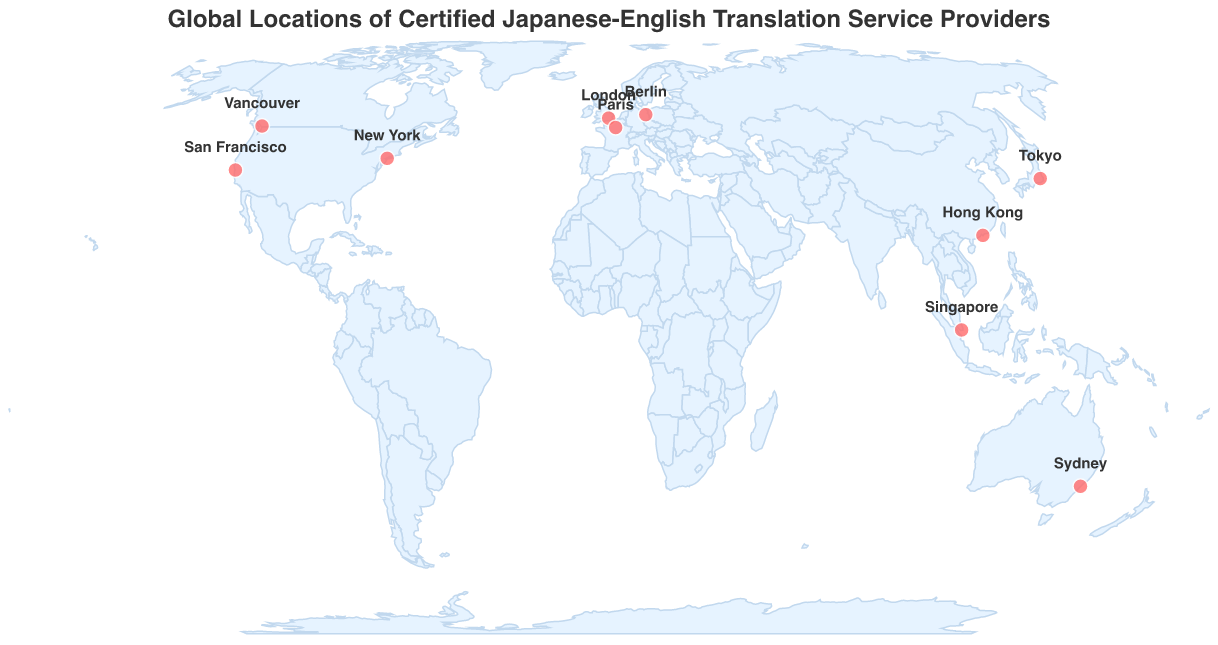Which city in the USA has a certified Japanese-English translation service provider? There are circles marking various cities. Looking at the USA, there are circles on New York and San Francisco.
Answer: New York, San Francisco How many cities in total have certified Japanese-English translation service providers based on the plot? Each circle represents a city with a service provider. Counting the circles on the map gives us the total number of cities.
Answer: 10 Which company has JTF certification and where is it located? Using the tooltips that show company details and certifications, find the company with JTF certification. The map shows that Nippon Translation Center in Tokyo has JTF certification.
Answer: Nippon Translation Center, Tokyo Which continent has the largest number of certified Japanese-English translation service providers? Visually group the locations by continent and count the number of cities in each. North America has the most with 4 cities (New York, San Francisco, Vancouver, and Mexico City).
Answer: North America What are the three companies located in Europe, and what are their certifications? Identifying the cities in Europe and checking their corresponding tooltip details, we find that the three companies in Europe are Japan Communication in London (ITI), Lingua-World in Berlin (ISO 9001), and Asiatis in Paris (SFT).
Answer: Japan Communication (ITI), Lingua-World (ISO 9001), Asiatis (SFT) Which service provider is located closest to the equator? The equator is at latitude 0. The provider closest to this latitude is ITNL Asia in Singapore with a latitude of 1.3521.
Answer: ITNL Asia How many cities have translation service providers with ATA certification? Using the tooltips to identify the certifications, count the cities with ATA certification. The cities are New York and San Francisco.
Answer: 2 Compare the certifications of the companies in Vancouver and Berlin. Which certification is more common among the listed service providers globally? Vancouver's service provider is certified by CTTIC, while Berlin's is certified by ISO 9001. Comparing the certification types on the map, we notice ISO 9001 appears more frequently (with Berlin and Singapore) compared to CTTIC (only Vancouver).
Answer: ISO 9001 Which service provider is farthest north based on the latitude provided? By comparing the latitude values of each city, the highest latitude corresponds to Vancouver, Canada, with a latitude of 49.2827.
Answer: MOSAIC Translation Services in Vancouver Do Tokyo and Hong Kong have different certifications for their translation service providers? By locating Tokyo and Hong Kong on the map and reviewing their tooltip details, we see that Tokyo has JTF certification, while Hong Kong has HKTS certification.
Answer: Yes 